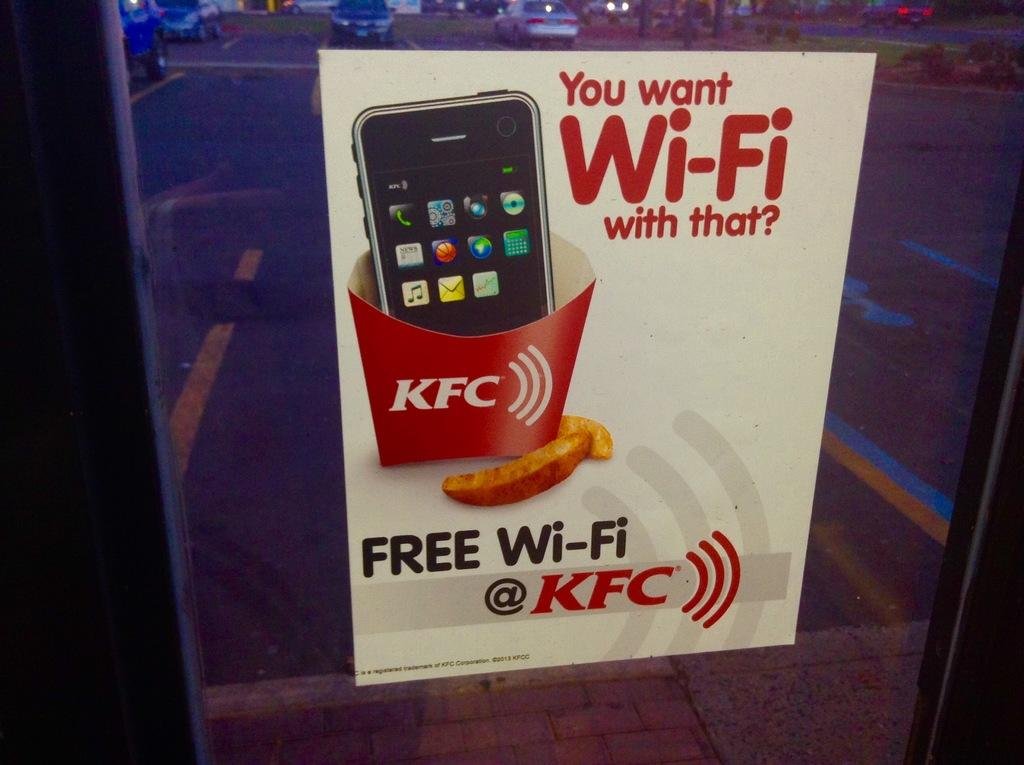<image>
Present a compact description of the photo's key features. A sign advertising the availability of free wi-fi access at a KFC 